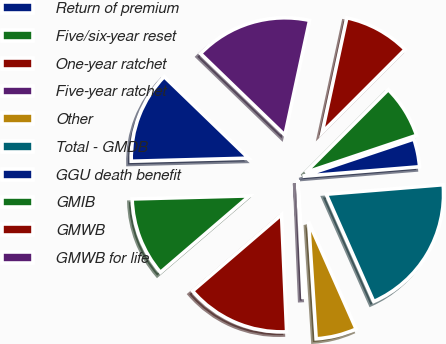Convert chart to OTSL. <chart><loc_0><loc_0><loc_500><loc_500><pie_chart><fcel>Return of premium<fcel>Five/six-year reset<fcel>One-year ratchet<fcel>Five-year ratchet<fcel>Other<fcel>Total - GMDB<fcel>GGU death benefit<fcel>GMIB<fcel>GMWB<fcel>GMWB for life<nl><fcel>12.64%<fcel>10.88%<fcel>14.39%<fcel>0.34%<fcel>5.61%<fcel>19.66%<fcel>3.85%<fcel>7.36%<fcel>9.12%<fcel>16.15%<nl></chart> 